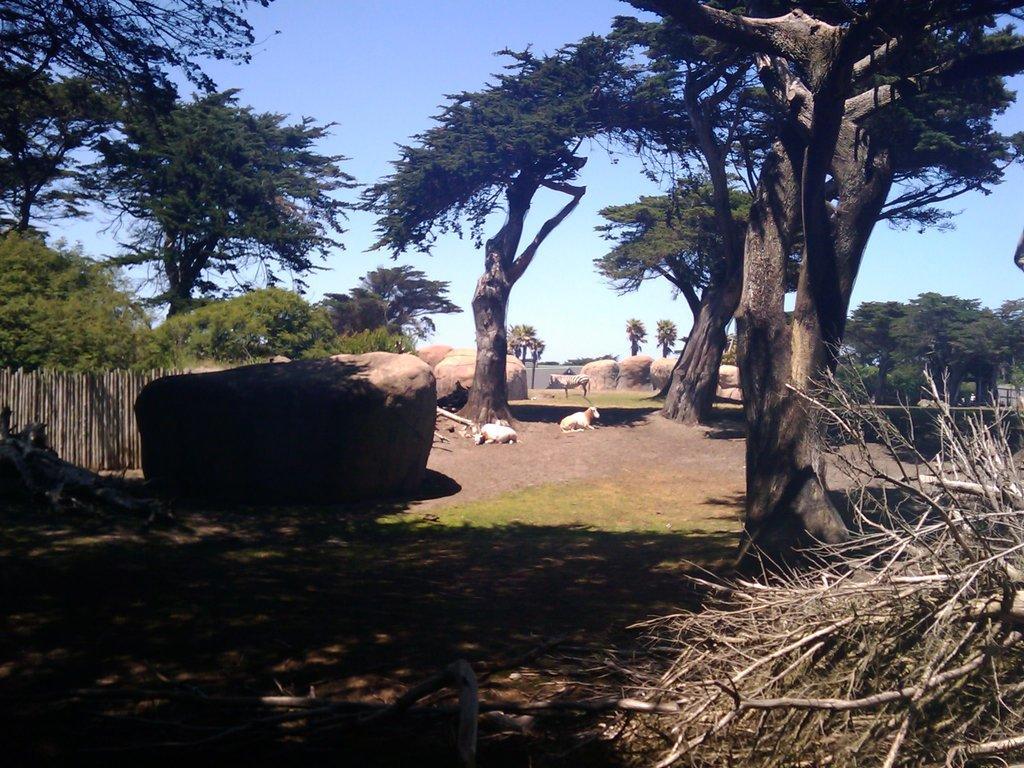How would you summarize this image in a sentence or two? In this picture we can see few animals, rocks and trees. 